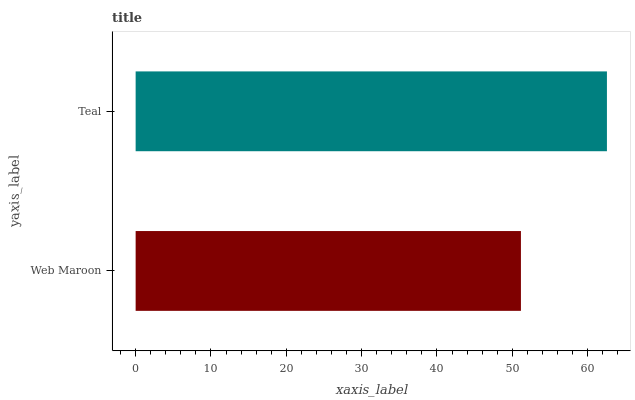Is Web Maroon the minimum?
Answer yes or no. Yes. Is Teal the maximum?
Answer yes or no. Yes. Is Teal the minimum?
Answer yes or no. No. Is Teal greater than Web Maroon?
Answer yes or no. Yes. Is Web Maroon less than Teal?
Answer yes or no. Yes. Is Web Maroon greater than Teal?
Answer yes or no. No. Is Teal less than Web Maroon?
Answer yes or no. No. Is Teal the high median?
Answer yes or no. Yes. Is Web Maroon the low median?
Answer yes or no. Yes. Is Web Maroon the high median?
Answer yes or no. No. Is Teal the low median?
Answer yes or no. No. 